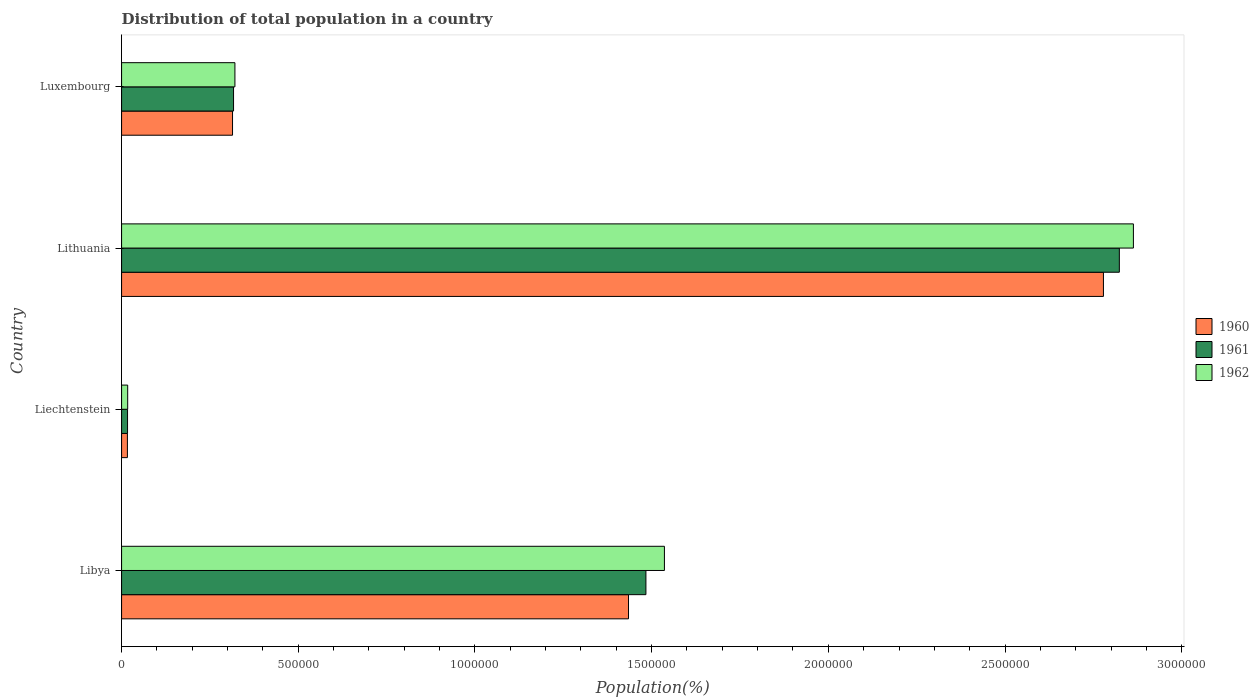How many different coloured bars are there?
Provide a short and direct response. 3. Are the number of bars per tick equal to the number of legend labels?
Offer a terse response. Yes. Are the number of bars on each tick of the Y-axis equal?
Provide a short and direct response. Yes. How many bars are there on the 3rd tick from the bottom?
Keep it short and to the point. 3. What is the label of the 4th group of bars from the top?
Ensure brevity in your answer.  Libya. In how many cases, is the number of bars for a given country not equal to the number of legend labels?
Ensure brevity in your answer.  0. What is the population of in 1960 in Luxembourg?
Ensure brevity in your answer.  3.14e+05. Across all countries, what is the maximum population of in 1961?
Provide a short and direct response. 2.82e+06. Across all countries, what is the minimum population of in 1961?
Your answer should be compact. 1.69e+04. In which country was the population of in 1961 maximum?
Make the answer very short. Lithuania. In which country was the population of in 1962 minimum?
Provide a succinct answer. Liechtenstein. What is the total population of in 1960 in the graph?
Offer a very short reply. 4.54e+06. What is the difference between the population of in 1962 in Libya and that in Liechtenstein?
Ensure brevity in your answer.  1.52e+06. What is the difference between the population of in 1962 in Luxembourg and the population of in 1960 in Libya?
Your answer should be very brief. -1.11e+06. What is the average population of in 1962 per country?
Make the answer very short. 1.18e+06. What is the difference between the population of in 1961 and population of in 1962 in Lithuania?
Offer a terse response. -3.98e+04. What is the ratio of the population of in 1961 in Libya to that in Luxembourg?
Your response must be concise. 4.68. Is the population of in 1962 in Libya less than that in Liechtenstein?
Offer a terse response. No. What is the difference between the highest and the second highest population of in 1960?
Make the answer very short. 1.34e+06. What is the difference between the highest and the lowest population of in 1962?
Your response must be concise. 2.85e+06. In how many countries, is the population of in 1960 greater than the average population of in 1960 taken over all countries?
Your answer should be compact. 2. What does the 3rd bar from the bottom in Liechtenstein represents?
Your response must be concise. 1962. Are all the bars in the graph horizontal?
Offer a terse response. Yes. What is the difference between two consecutive major ticks on the X-axis?
Provide a succinct answer. 5.00e+05. Does the graph contain grids?
Your response must be concise. No. Where does the legend appear in the graph?
Give a very brief answer. Center right. What is the title of the graph?
Provide a succinct answer. Distribution of total population in a country. Does "1966" appear as one of the legend labels in the graph?
Give a very brief answer. No. What is the label or title of the X-axis?
Your response must be concise. Population(%). What is the label or title of the Y-axis?
Provide a succinct answer. Country. What is the Population(%) in 1960 in Libya?
Your response must be concise. 1.43e+06. What is the Population(%) of 1961 in Libya?
Give a very brief answer. 1.48e+06. What is the Population(%) of 1962 in Libya?
Offer a very short reply. 1.54e+06. What is the Population(%) of 1960 in Liechtenstein?
Your answer should be very brief. 1.65e+04. What is the Population(%) of 1961 in Liechtenstein?
Give a very brief answer. 1.69e+04. What is the Population(%) in 1962 in Liechtenstein?
Make the answer very short. 1.73e+04. What is the Population(%) in 1960 in Lithuania?
Give a very brief answer. 2.78e+06. What is the Population(%) of 1961 in Lithuania?
Offer a very short reply. 2.82e+06. What is the Population(%) of 1962 in Lithuania?
Offer a terse response. 2.86e+06. What is the Population(%) in 1960 in Luxembourg?
Provide a short and direct response. 3.14e+05. What is the Population(%) in 1961 in Luxembourg?
Your response must be concise. 3.17e+05. What is the Population(%) of 1962 in Luxembourg?
Keep it short and to the point. 3.21e+05. Across all countries, what is the maximum Population(%) of 1960?
Offer a very short reply. 2.78e+06. Across all countries, what is the maximum Population(%) in 1961?
Provide a succinct answer. 2.82e+06. Across all countries, what is the maximum Population(%) in 1962?
Provide a short and direct response. 2.86e+06. Across all countries, what is the minimum Population(%) of 1960?
Your answer should be very brief. 1.65e+04. Across all countries, what is the minimum Population(%) in 1961?
Offer a terse response. 1.69e+04. Across all countries, what is the minimum Population(%) of 1962?
Ensure brevity in your answer.  1.73e+04. What is the total Population(%) of 1960 in the graph?
Your response must be concise. 4.54e+06. What is the total Population(%) of 1961 in the graph?
Your answer should be very brief. 4.64e+06. What is the total Population(%) of 1962 in the graph?
Your answer should be compact. 4.74e+06. What is the difference between the Population(%) in 1960 in Libya and that in Liechtenstein?
Your answer should be very brief. 1.42e+06. What is the difference between the Population(%) in 1961 in Libya and that in Liechtenstein?
Offer a terse response. 1.47e+06. What is the difference between the Population(%) of 1962 in Libya and that in Liechtenstein?
Give a very brief answer. 1.52e+06. What is the difference between the Population(%) in 1960 in Libya and that in Lithuania?
Offer a terse response. -1.34e+06. What is the difference between the Population(%) of 1961 in Libya and that in Lithuania?
Ensure brevity in your answer.  -1.34e+06. What is the difference between the Population(%) in 1962 in Libya and that in Lithuania?
Make the answer very short. -1.33e+06. What is the difference between the Population(%) in 1960 in Libya and that in Luxembourg?
Keep it short and to the point. 1.12e+06. What is the difference between the Population(%) in 1961 in Libya and that in Luxembourg?
Your answer should be very brief. 1.17e+06. What is the difference between the Population(%) of 1962 in Libya and that in Luxembourg?
Ensure brevity in your answer.  1.22e+06. What is the difference between the Population(%) in 1960 in Liechtenstein and that in Lithuania?
Provide a succinct answer. -2.76e+06. What is the difference between the Population(%) in 1961 in Liechtenstein and that in Lithuania?
Your answer should be very brief. -2.81e+06. What is the difference between the Population(%) in 1962 in Liechtenstein and that in Lithuania?
Ensure brevity in your answer.  -2.85e+06. What is the difference between the Population(%) in 1960 in Liechtenstein and that in Luxembourg?
Your response must be concise. -2.97e+05. What is the difference between the Population(%) in 1961 in Liechtenstein and that in Luxembourg?
Make the answer very short. -3.00e+05. What is the difference between the Population(%) of 1962 in Liechtenstein and that in Luxembourg?
Your answer should be very brief. -3.03e+05. What is the difference between the Population(%) in 1960 in Lithuania and that in Luxembourg?
Provide a short and direct response. 2.46e+06. What is the difference between the Population(%) in 1961 in Lithuania and that in Luxembourg?
Provide a succinct answer. 2.51e+06. What is the difference between the Population(%) in 1962 in Lithuania and that in Luxembourg?
Provide a succinct answer. 2.54e+06. What is the difference between the Population(%) of 1960 in Libya and the Population(%) of 1961 in Liechtenstein?
Provide a succinct answer. 1.42e+06. What is the difference between the Population(%) in 1960 in Libya and the Population(%) in 1962 in Liechtenstein?
Your response must be concise. 1.42e+06. What is the difference between the Population(%) of 1961 in Libya and the Population(%) of 1962 in Liechtenstein?
Your answer should be compact. 1.47e+06. What is the difference between the Population(%) in 1960 in Libya and the Population(%) in 1961 in Lithuania?
Your answer should be very brief. -1.39e+06. What is the difference between the Population(%) of 1960 in Libya and the Population(%) of 1962 in Lithuania?
Your answer should be compact. -1.43e+06. What is the difference between the Population(%) in 1961 in Libya and the Population(%) in 1962 in Lithuania?
Your answer should be very brief. -1.38e+06. What is the difference between the Population(%) in 1960 in Libya and the Population(%) in 1961 in Luxembourg?
Your answer should be compact. 1.12e+06. What is the difference between the Population(%) of 1960 in Libya and the Population(%) of 1962 in Luxembourg?
Offer a very short reply. 1.11e+06. What is the difference between the Population(%) in 1961 in Libya and the Population(%) in 1962 in Luxembourg?
Provide a short and direct response. 1.16e+06. What is the difference between the Population(%) in 1960 in Liechtenstein and the Population(%) in 1961 in Lithuania?
Provide a short and direct response. -2.81e+06. What is the difference between the Population(%) in 1960 in Liechtenstein and the Population(%) in 1962 in Lithuania?
Offer a terse response. -2.85e+06. What is the difference between the Population(%) in 1961 in Liechtenstein and the Population(%) in 1962 in Lithuania?
Make the answer very short. -2.85e+06. What is the difference between the Population(%) of 1960 in Liechtenstein and the Population(%) of 1961 in Luxembourg?
Provide a short and direct response. -3.00e+05. What is the difference between the Population(%) in 1960 in Liechtenstein and the Population(%) in 1962 in Luxembourg?
Give a very brief answer. -3.04e+05. What is the difference between the Population(%) in 1961 in Liechtenstein and the Population(%) in 1962 in Luxembourg?
Ensure brevity in your answer.  -3.04e+05. What is the difference between the Population(%) in 1960 in Lithuania and the Population(%) in 1961 in Luxembourg?
Your response must be concise. 2.46e+06. What is the difference between the Population(%) of 1960 in Lithuania and the Population(%) of 1962 in Luxembourg?
Offer a very short reply. 2.46e+06. What is the difference between the Population(%) in 1961 in Lithuania and the Population(%) in 1962 in Luxembourg?
Your answer should be very brief. 2.50e+06. What is the average Population(%) in 1960 per country?
Provide a succinct answer. 1.14e+06. What is the average Population(%) in 1961 per country?
Your answer should be compact. 1.16e+06. What is the average Population(%) of 1962 per country?
Your answer should be very brief. 1.18e+06. What is the difference between the Population(%) of 1960 and Population(%) of 1961 in Libya?
Offer a terse response. -4.93e+04. What is the difference between the Population(%) of 1960 and Population(%) of 1962 in Libya?
Make the answer very short. -1.02e+05. What is the difference between the Population(%) of 1961 and Population(%) of 1962 in Libya?
Offer a terse response. -5.23e+04. What is the difference between the Population(%) of 1960 and Population(%) of 1961 in Liechtenstein?
Your response must be concise. -390. What is the difference between the Population(%) of 1960 and Population(%) of 1962 in Liechtenstein?
Ensure brevity in your answer.  -794. What is the difference between the Population(%) in 1961 and Population(%) in 1962 in Liechtenstein?
Provide a succinct answer. -404. What is the difference between the Population(%) in 1960 and Population(%) in 1961 in Lithuania?
Ensure brevity in your answer.  -4.50e+04. What is the difference between the Population(%) of 1960 and Population(%) of 1962 in Lithuania?
Your answer should be very brief. -8.48e+04. What is the difference between the Population(%) in 1961 and Population(%) in 1962 in Lithuania?
Provide a short and direct response. -3.98e+04. What is the difference between the Population(%) in 1960 and Population(%) in 1961 in Luxembourg?
Ensure brevity in your answer.  -2875. What is the difference between the Population(%) of 1960 and Population(%) of 1962 in Luxembourg?
Give a very brief answer. -6780. What is the difference between the Population(%) of 1961 and Population(%) of 1962 in Luxembourg?
Offer a terse response. -3905. What is the ratio of the Population(%) of 1960 in Libya to that in Liechtenstein?
Ensure brevity in your answer.  86.92. What is the ratio of the Population(%) in 1961 in Libya to that in Liechtenstein?
Provide a short and direct response. 87.83. What is the ratio of the Population(%) of 1962 in Libya to that in Liechtenstein?
Your answer should be compact. 88.81. What is the ratio of the Population(%) in 1960 in Libya to that in Lithuania?
Give a very brief answer. 0.52. What is the ratio of the Population(%) of 1961 in Libya to that in Lithuania?
Make the answer very short. 0.53. What is the ratio of the Population(%) in 1962 in Libya to that in Lithuania?
Make the answer very short. 0.54. What is the ratio of the Population(%) in 1960 in Libya to that in Luxembourg?
Give a very brief answer. 4.57. What is the ratio of the Population(%) of 1961 in Libya to that in Luxembourg?
Your response must be concise. 4.68. What is the ratio of the Population(%) of 1962 in Libya to that in Luxembourg?
Provide a succinct answer. 4.79. What is the ratio of the Population(%) of 1960 in Liechtenstein to that in Lithuania?
Provide a short and direct response. 0.01. What is the ratio of the Population(%) of 1961 in Liechtenstein to that in Lithuania?
Provide a short and direct response. 0.01. What is the ratio of the Population(%) in 1962 in Liechtenstein to that in Lithuania?
Offer a terse response. 0.01. What is the ratio of the Population(%) in 1960 in Liechtenstein to that in Luxembourg?
Make the answer very short. 0.05. What is the ratio of the Population(%) of 1961 in Liechtenstein to that in Luxembourg?
Offer a very short reply. 0.05. What is the ratio of the Population(%) of 1962 in Liechtenstein to that in Luxembourg?
Give a very brief answer. 0.05. What is the ratio of the Population(%) in 1960 in Lithuania to that in Luxembourg?
Provide a succinct answer. 8.85. What is the ratio of the Population(%) in 1961 in Lithuania to that in Luxembourg?
Your answer should be compact. 8.91. What is the ratio of the Population(%) of 1962 in Lithuania to that in Luxembourg?
Offer a terse response. 8.93. What is the difference between the highest and the second highest Population(%) in 1960?
Provide a short and direct response. 1.34e+06. What is the difference between the highest and the second highest Population(%) in 1961?
Make the answer very short. 1.34e+06. What is the difference between the highest and the second highest Population(%) in 1962?
Your answer should be very brief. 1.33e+06. What is the difference between the highest and the lowest Population(%) in 1960?
Make the answer very short. 2.76e+06. What is the difference between the highest and the lowest Population(%) of 1961?
Provide a succinct answer. 2.81e+06. What is the difference between the highest and the lowest Population(%) of 1962?
Make the answer very short. 2.85e+06. 